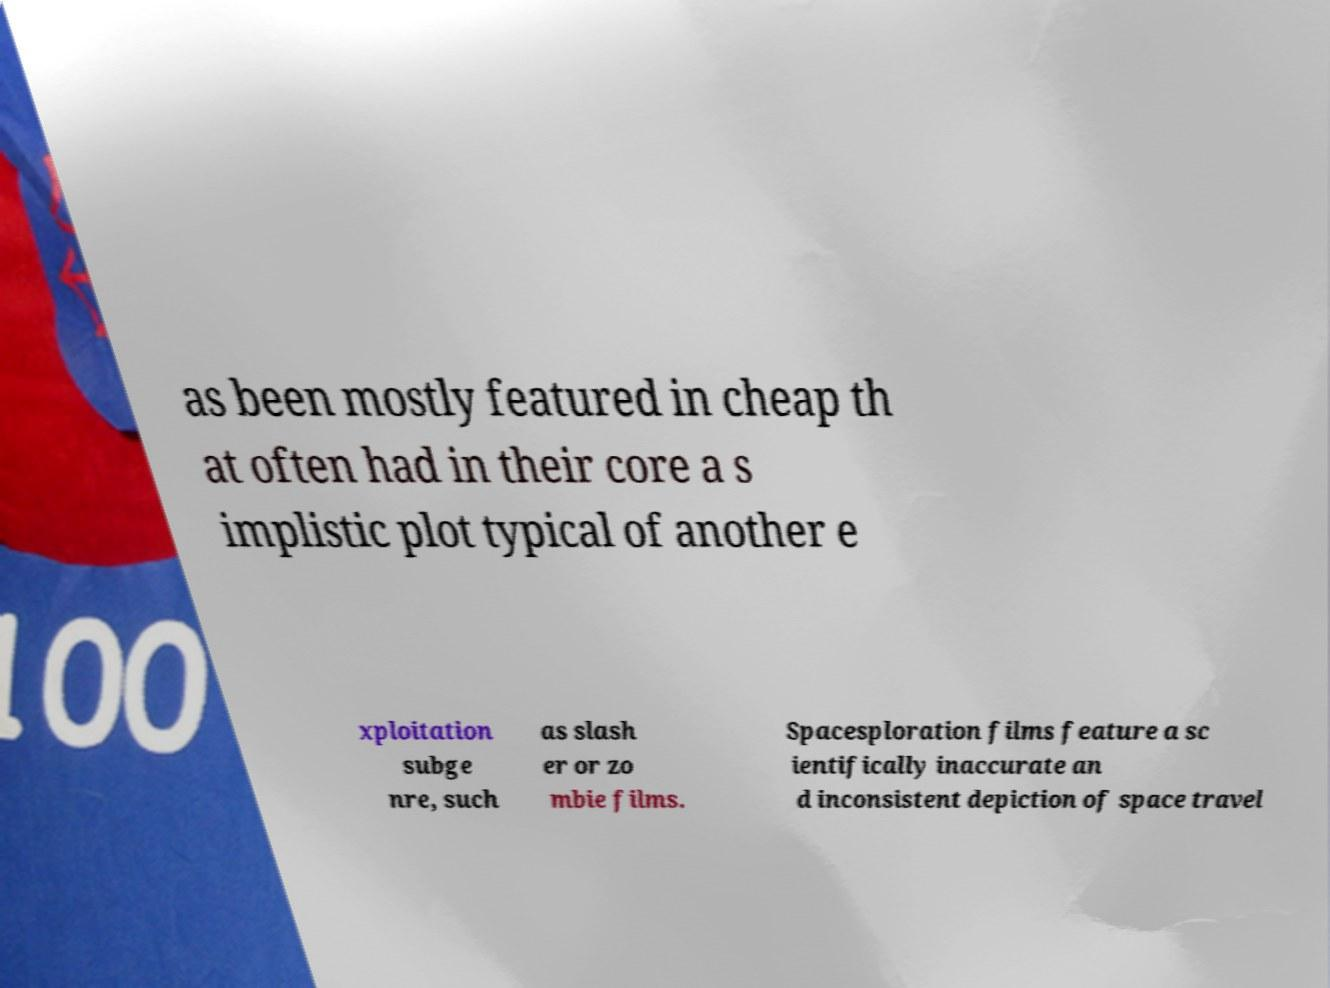Can you read and provide the text displayed in the image?This photo seems to have some interesting text. Can you extract and type it out for me? as been mostly featured in cheap th at often had in their core a s implistic plot typical of another e xploitation subge nre, such as slash er or zo mbie films. Spacesploration films feature a sc ientifically inaccurate an d inconsistent depiction of space travel 